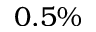<formula> <loc_0><loc_0><loc_500><loc_500>0 . 5 \%</formula> 